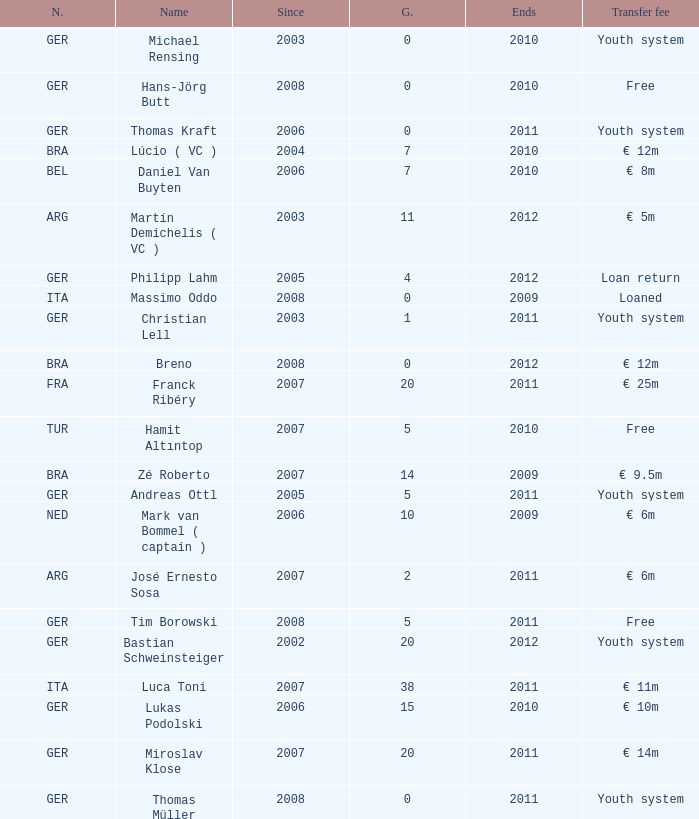What is the total number of ends after 2006 with a nationality of ita and 0 goals? 0.0. Would you be able to parse every entry in this table? {'header': ['N.', 'Name', 'Since', 'G.', 'Ends', 'Transfer fee'], 'rows': [['GER', 'Michael Rensing', '2003', '0', '2010', 'Youth system'], ['GER', 'Hans-Jörg Butt', '2008', '0', '2010', 'Free'], ['GER', 'Thomas Kraft', '2006', '0', '2011', 'Youth system'], ['BRA', 'Lúcio ( VC )', '2004', '7', '2010', '€ 12m'], ['BEL', 'Daniel Van Buyten', '2006', '7', '2010', '€ 8m'], ['ARG', 'Martín Demichelis ( VC )', '2003', '11', '2012', '€ 5m'], ['GER', 'Philipp Lahm', '2005', '4', '2012', 'Loan return'], ['ITA', 'Massimo Oddo', '2008', '0', '2009', 'Loaned'], ['GER', 'Christian Lell', '2003', '1', '2011', 'Youth system'], ['BRA', 'Breno', '2008', '0', '2012', '€ 12m'], ['FRA', 'Franck Ribéry', '2007', '20', '2011', '€ 25m'], ['TUR', 'Hamit Altıntop', '2007', '5', '2010', 'Free'], ['BRA', 'Zé Roberto', '2007', '14', '2009', '€ 9.5m'], ['GER', 'Andreas Ottl', '2005', '5', '2011', 'Youth system'], ['NED', 'Mark van Bommel ( captain )', '2006', '10', '2009', '€ 6m'], ['ARG', 'José Ernesto Sosa', '2007', '2', '2011', '€ 6m'], ['GER', 'Tim Borowski', '2008', '5', '2011', 'Free'], ['GER', 'Bastian Schweinsteiger', '2002', '20', '2012', 'Youth system'], ['ITA', 'Luca Toni', '2007', '38', '2011', '€ 11m'], ['GER', 'Lukas Podolski', '2006', '15', '2010', '€ 10m'], ['GER', 'Miroslav Klose', '2007', '20', '2011', '€ 14m'], ['GER', 'Thomas Müller', '2008', '0', '2011', 'Youth system']]} 